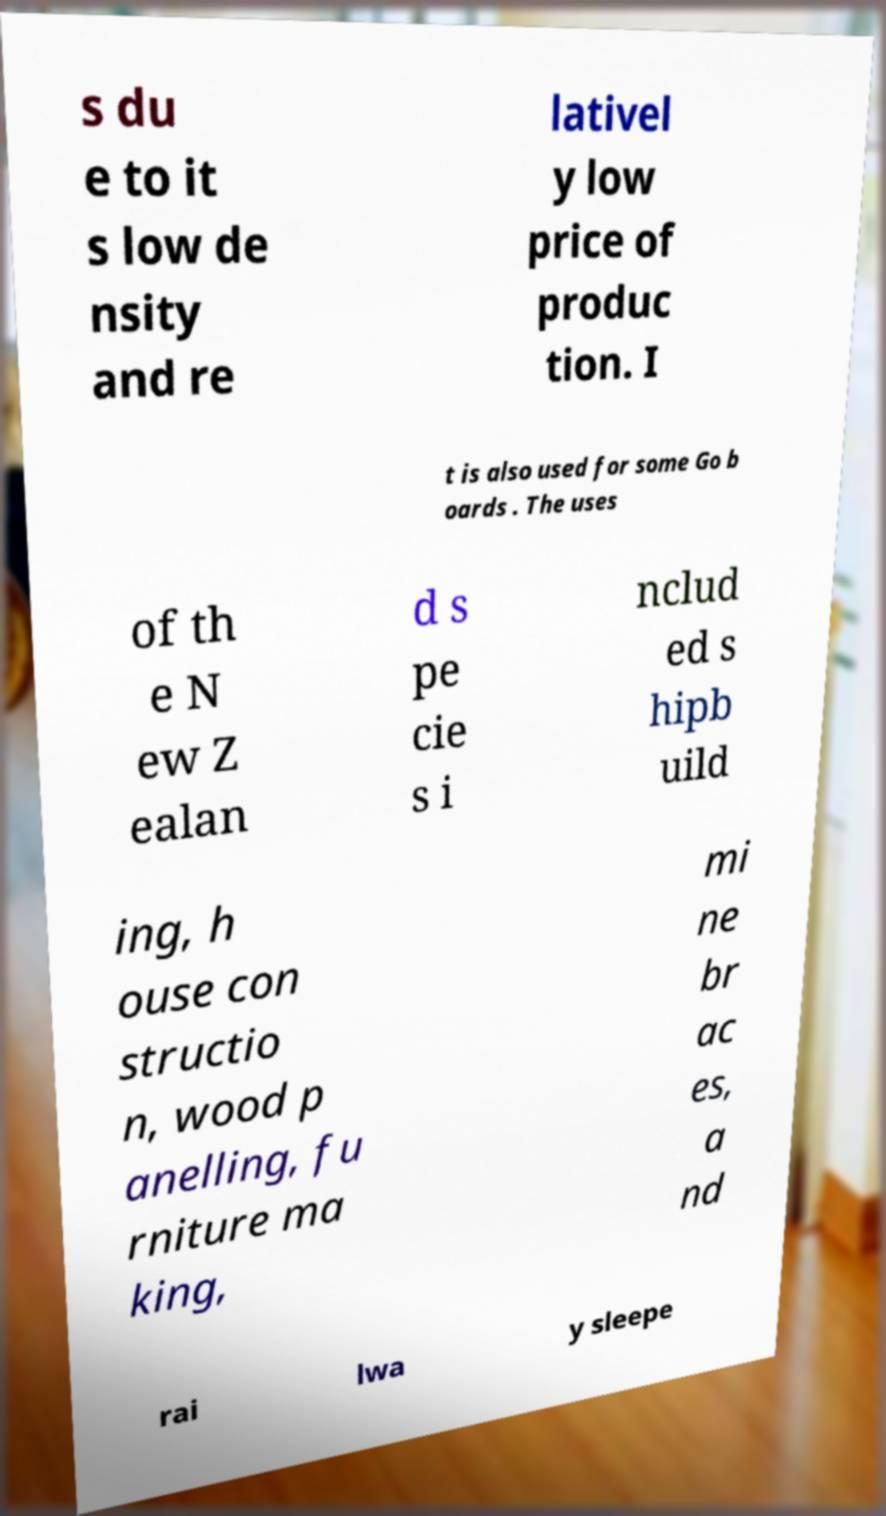There's text embedded in this image that I need extracted. Can you transcribe it verbatim? s du e to it s low de nsity and re lativel y low price of produc tion. I t is also used for some Go b oards . The uses of th e N ew Z ealan d s pe cie s i nclud ed s hipb uild ing, h ouse con structio n, wood p anelling, fu rniture ma king, mi ne br ac es, a nd rai lwa y sleepe 